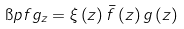<formula> <loc_0><loc_0><loc_500><loc_500>\i p { f } { g } _ { z } = \xi \left ( z \right ) \bar { f } \left ( z \right ) g \left ( z \right )</formula> 